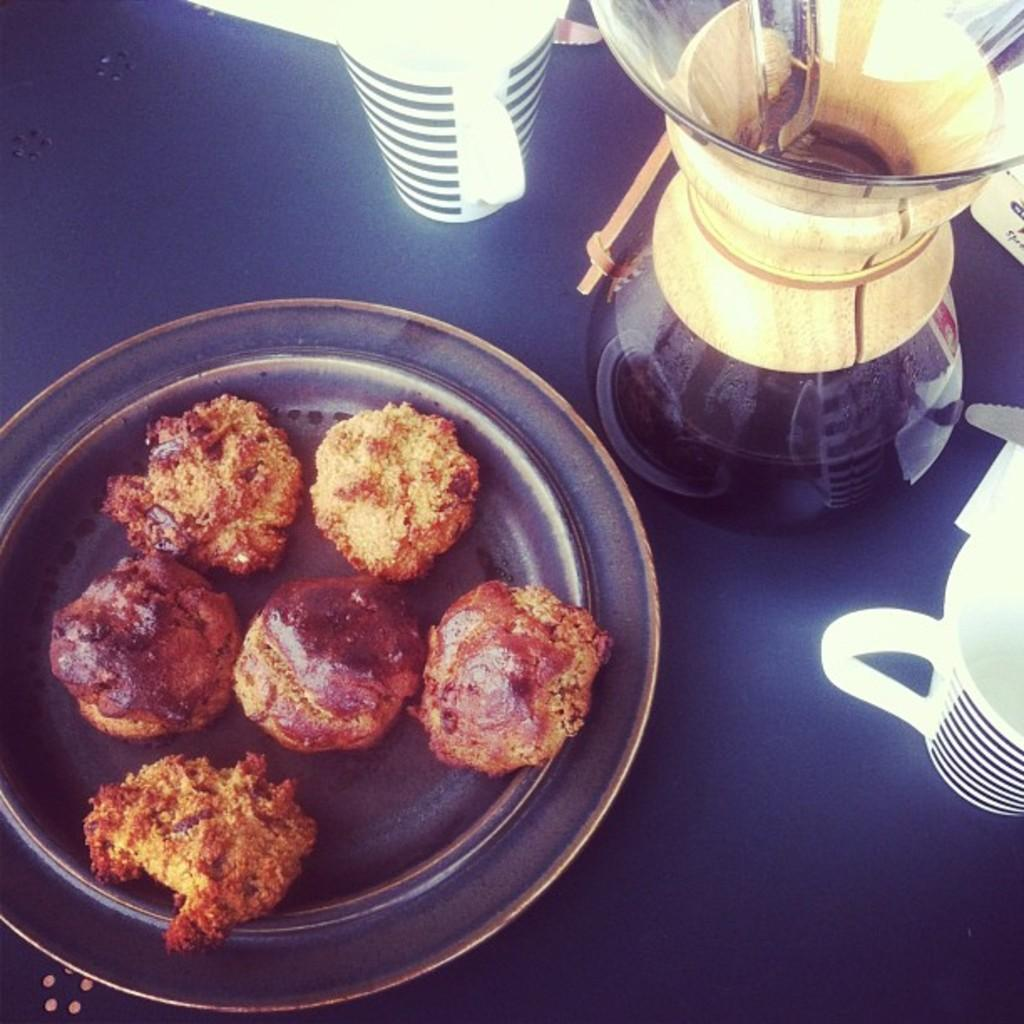What is on the plate that is visible in the image? There is a plate with food in the image. What other items can be seen in the image? There is a flask and two cups visible in the image. What is the color of the surface in the image? The surface in the image is blue. How many snakes are slithering on the blue surface in the image? There are no snakes present in the image; the focus is on the plate with food, flask, and cups. 